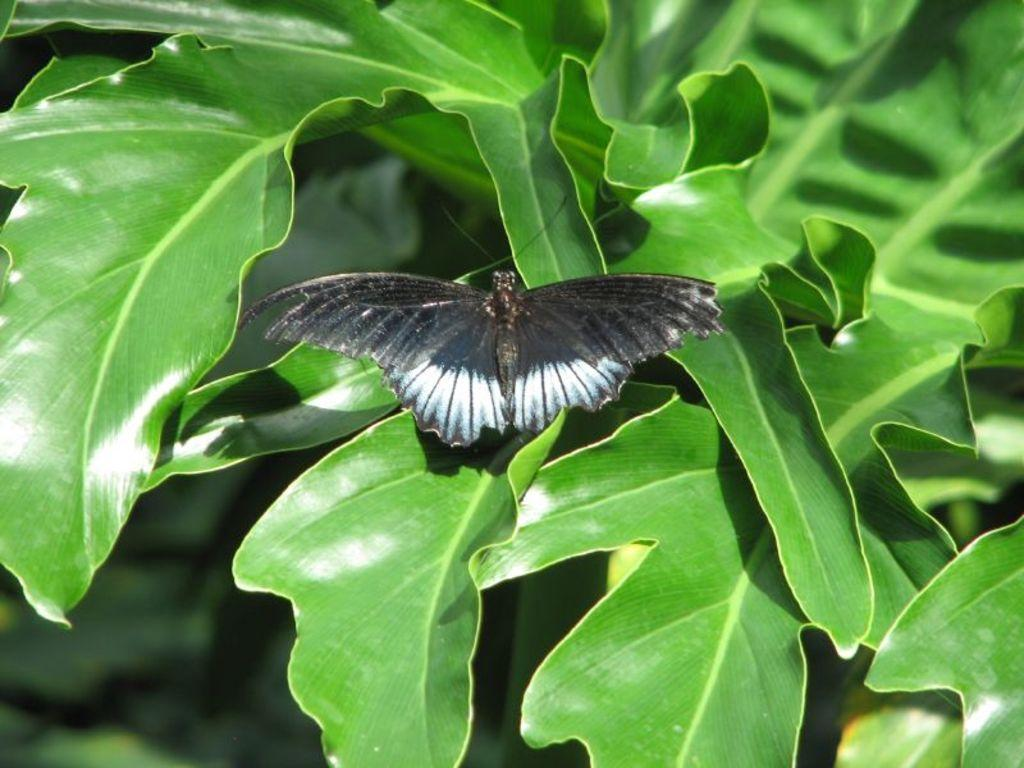What type of insect is in the image? There is a black butterfly in the image. What is the butterfly sitting on? The butterfly is sitting on green leaves. What type of star can be seen in the image? There is no star present in the image; it features a black butterfly sitting on green leaves. What is the relation between the butterfly and the office in the image? There is no office present in the image, so it is not possible to determine any relation between the butterfly and an office. 